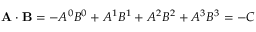<formula> <loc_0><loc_0><loc_500><loc_500>A \cdot B = - A ^ { 0 } B ^ { 0 } + A ^ { 1 } B ^ { 1 } + A ^ { 2 } B ^ { 2 } + A ^ { 3 } B ^ { 3 } = - C</formula> 